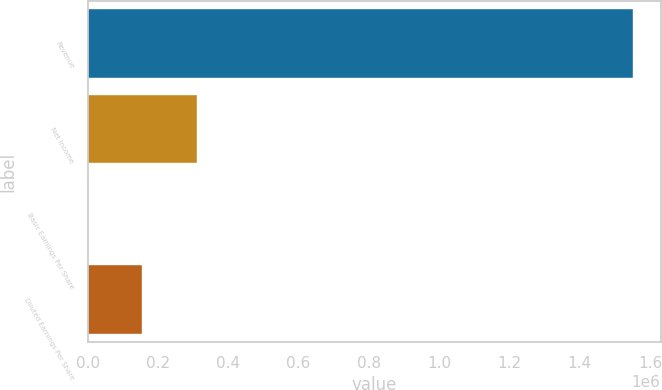Convert chart. <chart><loc_0><loc_0><loc_500><loc_500><bar_chart><fcel>Revenue<fcel>Net Income<fcel>Basic Earnings Per Share<fcel>Diluted Earnings Per Share<nl><fcel>1.55269e+06<fcel>310541<fcel>3.52<fcel>155272<nl></chart> 